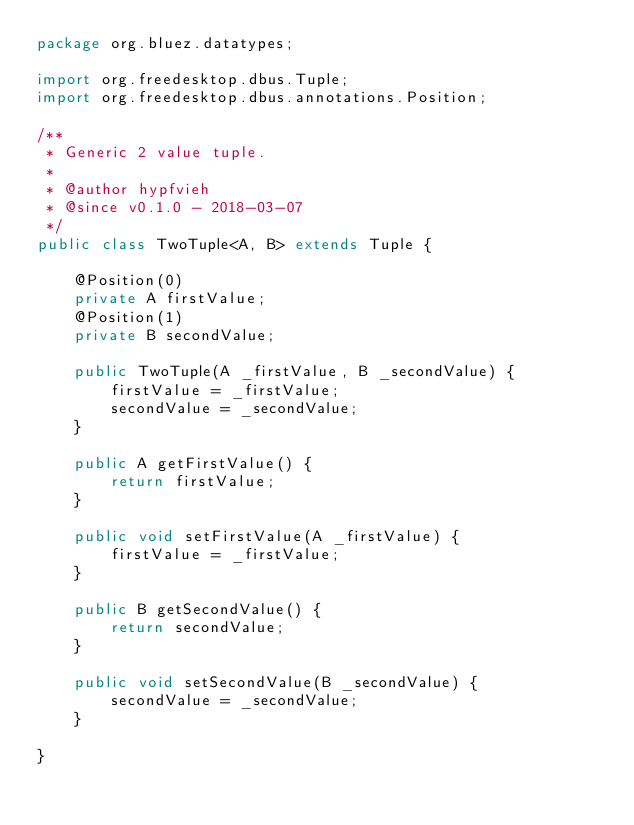Convert code to text. <code><loc_0><loc_0><loc_500><loc_500><_Java_>package org.bluez.datatypes;

import org.freedesktop.dbus.Tuple;
import org.freedesktop.dbus.annotations.Position;

/**
 * Generic 2 value tuple.
 *
 * @author hypfvieh
 * @since v0.1.0 - 2018-03-07
 */
public class TwoTuple<A, B> extends Tuple {

    @Position(0)
    private A firstValue;
    @Position(1)
    private B secondValue;

    public TwoTuple(A _firstValue, B _secondValue) {
        firstValue = _firstValue;
        secondValue = _secondValue;
    }

    public A getFirstValue() {
        return firstValue;
    }

    public void setFirstValue(A _firstValue) {
        firstValue = _firstValue;
    }

    public B getSecondValue() {
        return secondValue;
    }

    public void setSecondValue(B _secondValue) {
        secondValue = _secondValue;
    }

}
</code> 